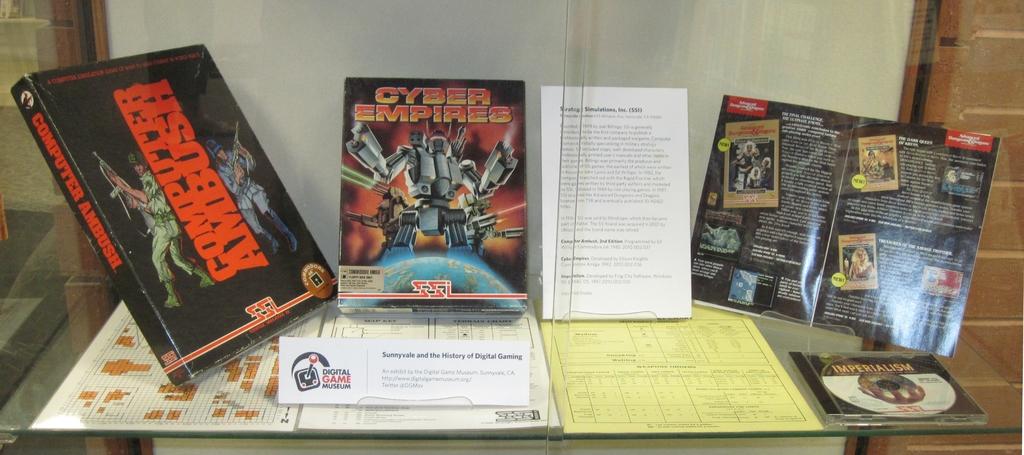Do they have cyber empires?
Your answer should be very brief. Yes. What is the name of the game on the left?
Offer a very short reply. Computer ambush. 